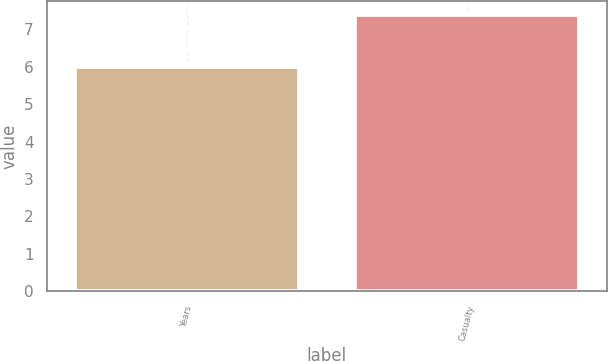Convert chart. <chart><loc_0><loc_0><loc_500><loc_500><bar_chart><fcel>Years<fcel>Casualty<nl><fcel>6<fcel>7.4<nl></chart> 